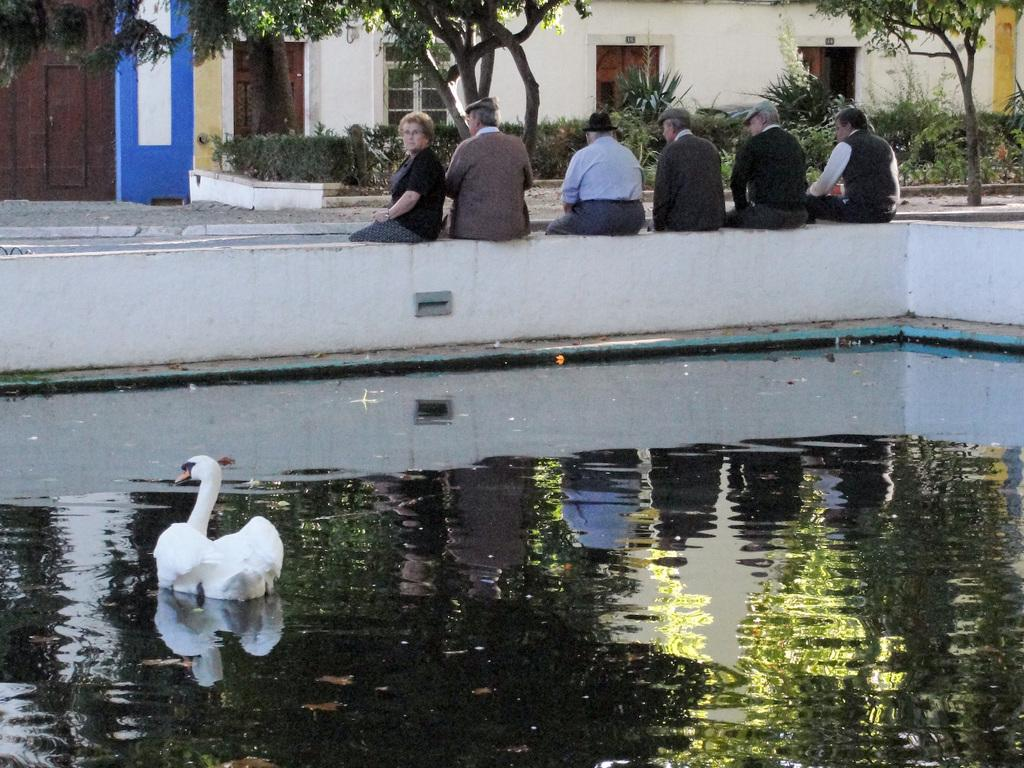What type of animal is in the water in the image? There is a white duck in the water in the image. What are the people in the image doing? The people in the image are seated. What structures can be seen in the background of the image? There are buildings visible in the image. What type of vegetation is present in the image? There are trees in the image. What type of headwear is worn by some people in the image? Some people are wearing caps, and a man is wearing a hat. What type of form is being filled out by the people in the image? There is no form present in the image; the people are seated. What type of pie is being served to the people in the image? There is no pie present in the image. What type of battle is taking place in the image? There is no battle present in the image. 